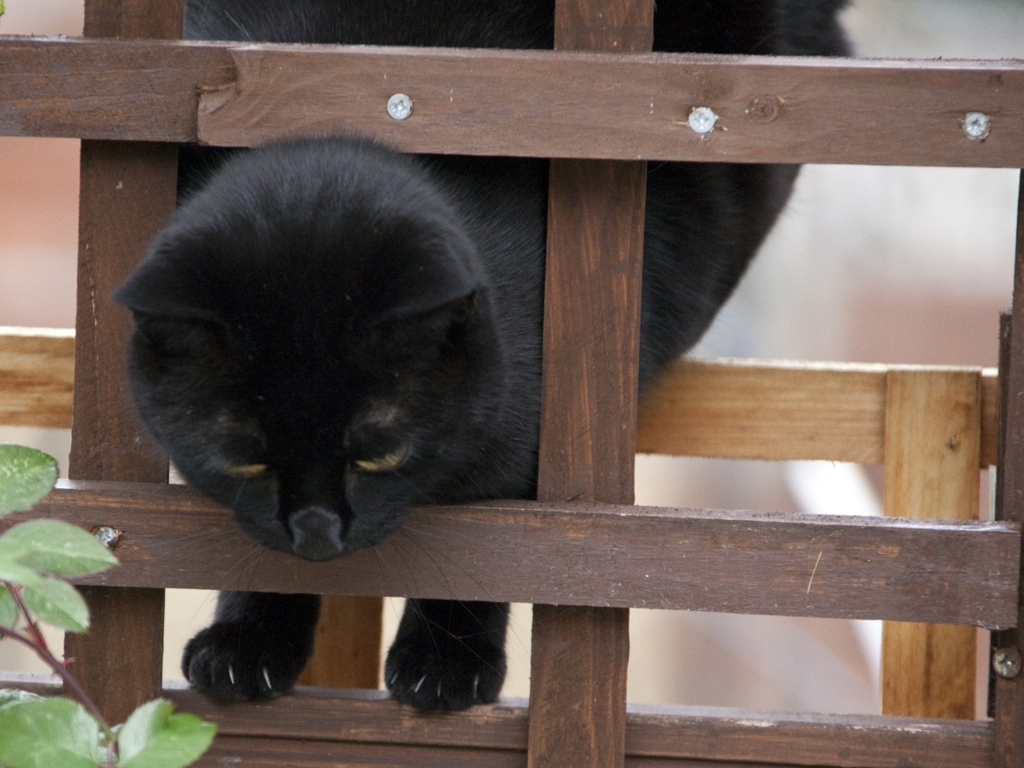Are the textures of the main subject clear?
A. Yes
B. No
Answer with the option's letter from the given choices directly.
 A. 